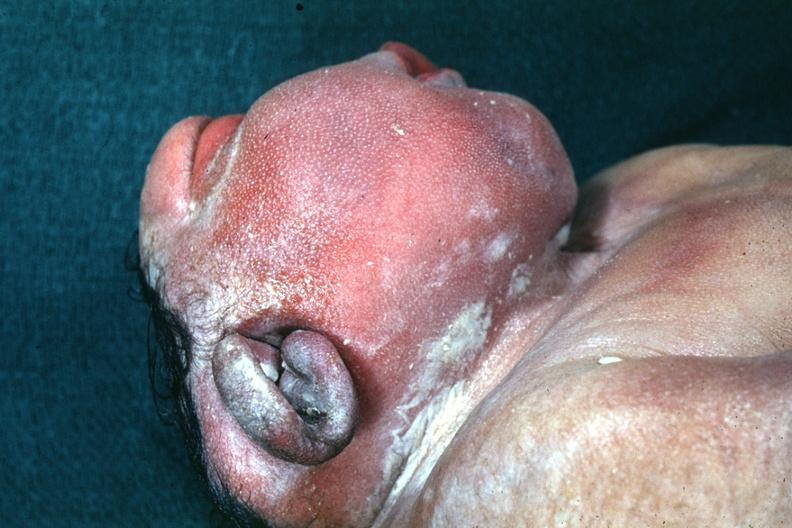s anencephaly present?
Answer the question using a single word or phrase. Yes 